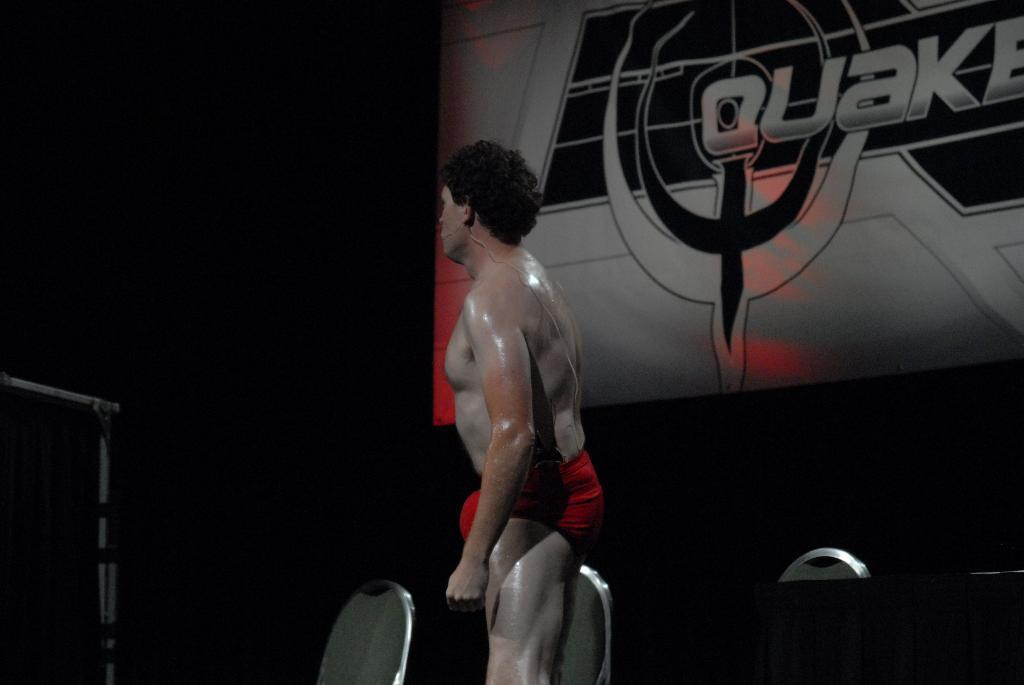What is the main subject in the image? There is a person standing in the image. What objects are present in the image besides the person? There are chairs and a board in the image. What is the color of the background in the image? The background of the image is black. What sound can be heard coming from the person's finger in the image? There is no sound or finger mentioned in the image, so it is not possible to determine what sound might be heard. 